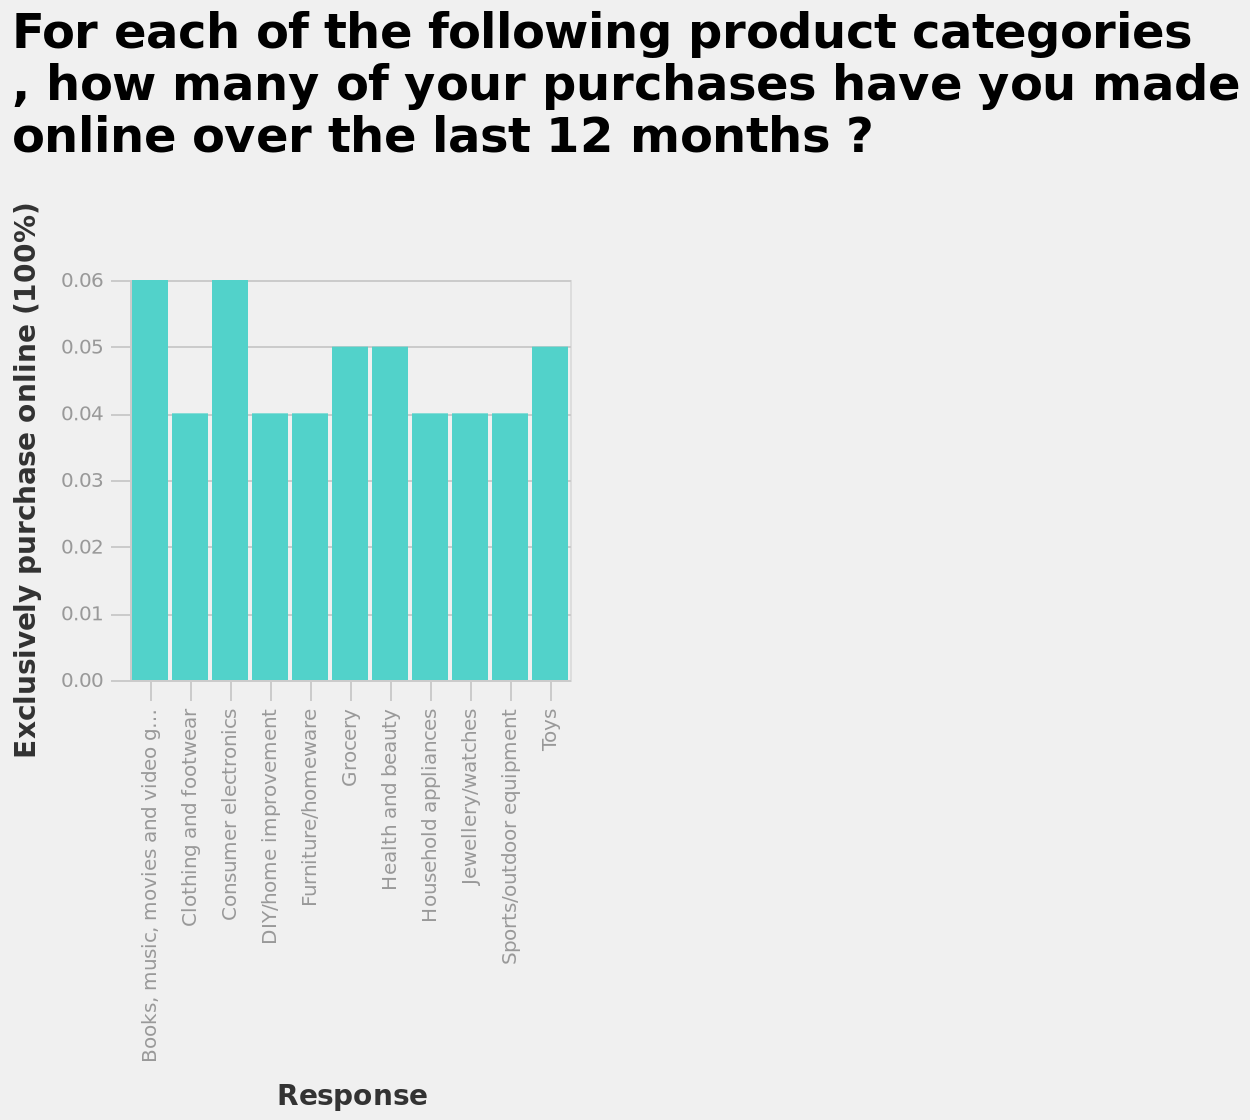<image>
please describe the details of the chart For each of the following product categories , how many of your purchases have you made online over the last 12 months ? is a bar diagram. Response is defined along a categorical scale starting with Books, music, movies and video games and ending with Toys on the x-axis. Along the y-axis, Exclusively purchase online (100%) is measured using a linear scale with a minimum of 0.00 and a maximum of 0.06. What are the product categories represented on the x-axis of the bar diagram?  The product categories represented on the x-axis of the bar diagram are Books, music, movies and video games, and Toys. Can you provide examples of the types of products that have seen a surge in online purchases in the last year? Examples of products that have seen a surge in online purchases in the last year include books, music, movies, videos, and consumer electronics. 